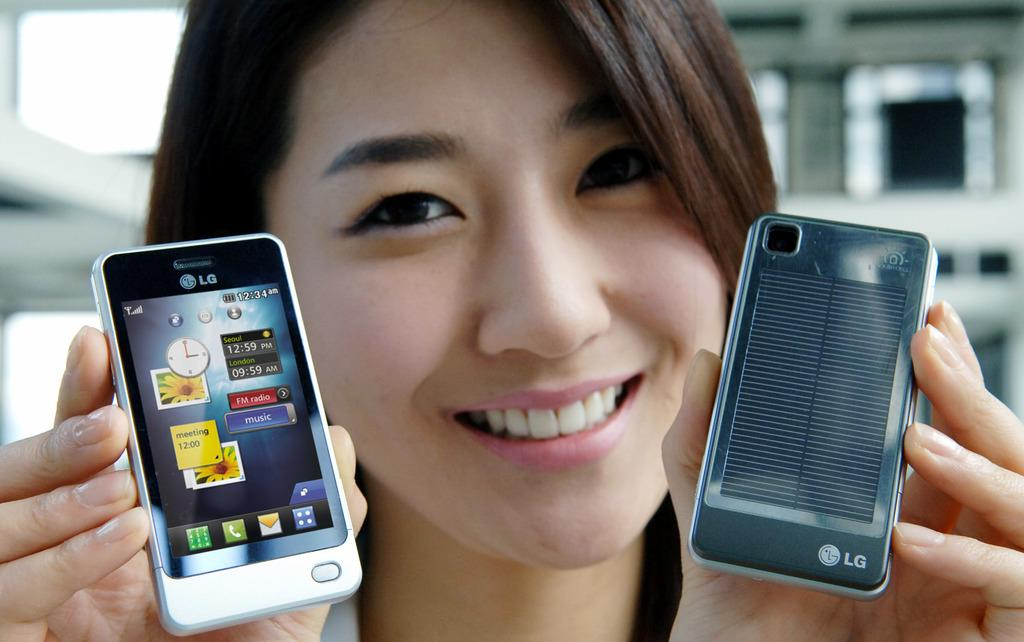<image>
Create a compact narrative representing the image presented. a woman holding up a black and a white LG phone 